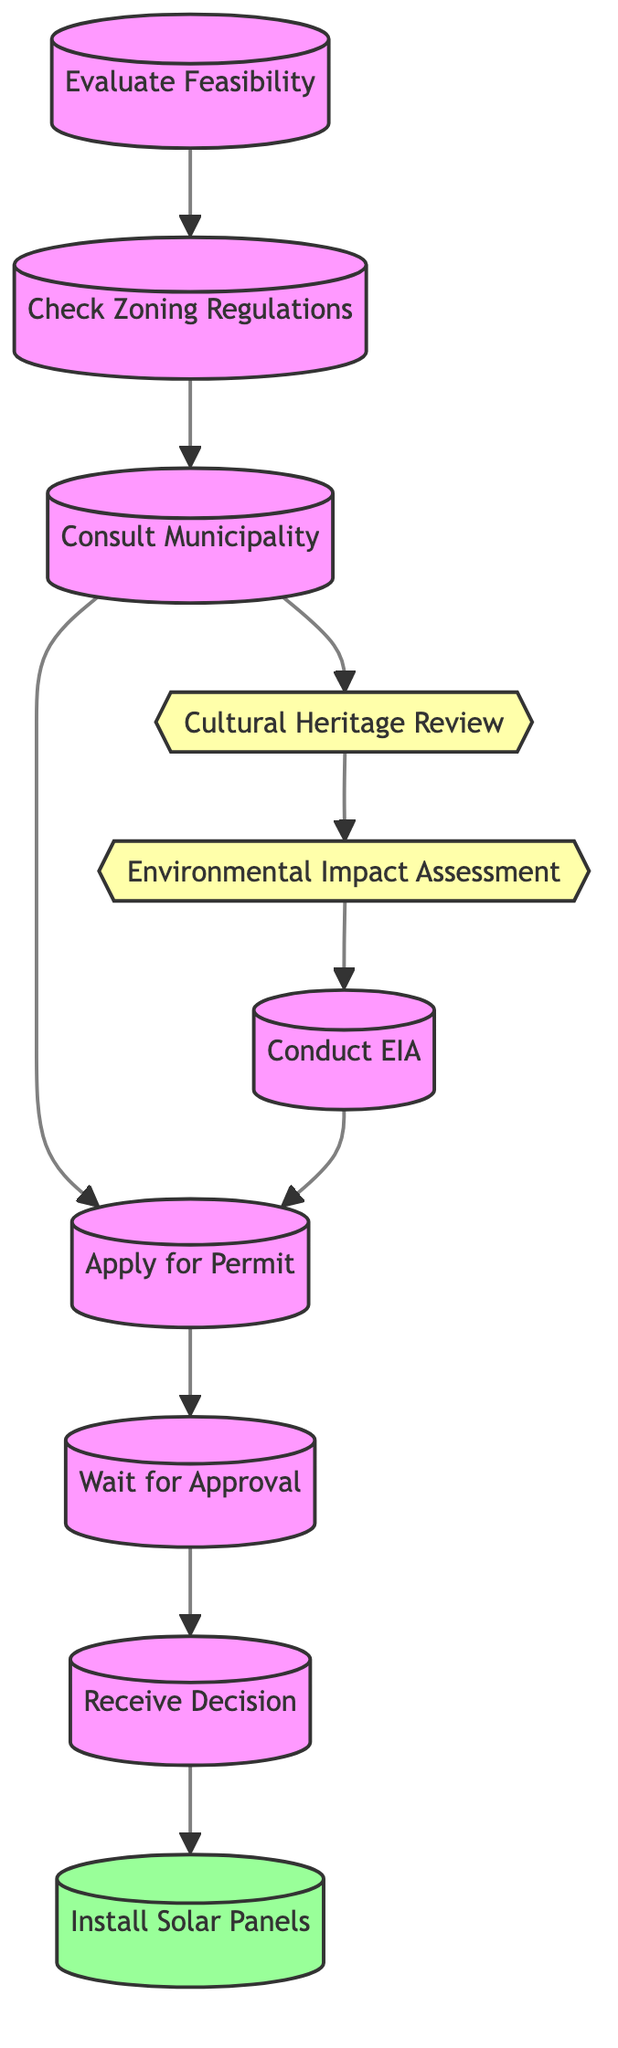What is the first step in the process? The diagram starts with the node "Evaluate Feasibility," which indicates the first action to take in the permit application process for solar panel installation.
Answer: Evaluate Feasibility How many conditional nodes are in the diagram? By examining the diagram, there are two conditional nodes: "Cultural Heritage Review" and "Environmental Impact Assessment."
Answer: 2 What comes after "Check Zoning Regulations"? Following the "Check Zoning Regulations" node, the flow goes to "Consult Municipality," indicating the next step in the process after assessing zoning compliance.
Answer: Consult Municipality If a building is a designated monument, what is the next step to follow? If the building is a designated monument, the process requires the completion of the "Cultural Heritage Review," leading to the need for an approval before proceeding further.
Answer: Cultural Heritage Review What is the outcome of the process if the permit is granted? Upon receiving the permit approval, the final action to take is "Install Solar Panels," indicating the successful conclusion of the permit acquisition process.
Answer: Install Solar Panels What happens if an Environmental Impact Assessment is deemed necessary? If an environmental impact assessment is necessary, the flow requires conducting the EIA to ensure that any potential environmental impacts are addressed before applying for the permit.
Answer: Conduct EIA How long does the municipality review the application? The application review process by the municipality can take up to eight weeks, which is stated in the "Wait for Approval" node.
Answer: eight weeks What step follows receiving the municipality's decision? The final step that follows the municipality's decision is to either install solar panels if approved or address any issues and reapply if the permit is rejected.
Answer: Install Solar Panels 